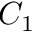Convert formula to latex. <formula><loc_0><loc_0><loc_500><loc_500>C _ { 1 }</formula> 